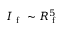Convert formula to latex. <formula><loc_0><loc_0><loc_500><loc_500>I _ { f } \sim R _ { f } ^ { 5 }</formula> 